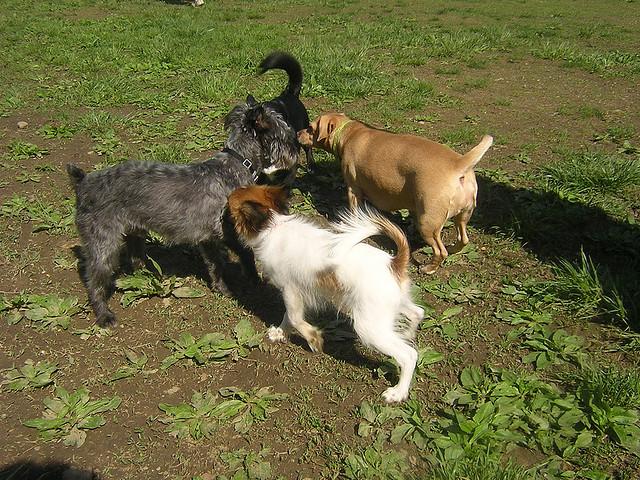How many animals are there?
Be succinct. 4. Is this photo clear?
Quick response, please. Yes. How many pets are shown?
Concise answer only. 4. What animals are these?
Short answer required. Dogs. What color is the dog?
Write a very short answer. White. Do these dogs like each other?
Short answer required. Yes. Are there any kittens in the picture?
Write a very short answer. No. 